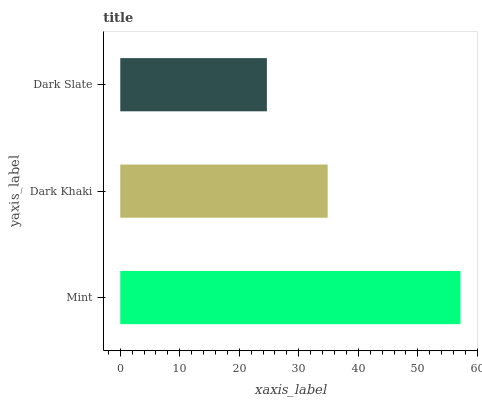Is Dark Slate the minimum?
Answer yes or no. Yes. Is Mint the maximum?
Answer yes or no. Yes. Is Dark Khaki the minimum?
Answer yes or no. No. Is Dark Khaki the maximum?
Answer yes or no. No. Is Mint greater than Dark Khaki?
Answer yes or no. Yes. Is Dark Khaki less than Mint?
Answer yes or no. Yes. Is Dark Khaki greater than Mint?
Answer yes or no. No. Is Mint less than Dark Khaki?
Answer yes or no. No. Is Dark Khaki the high median?
Answer yes or no. Yes. Is Dark Khaki the low median?
Answer yes or no. Yes. Is Dark Slate the high median?
Answer yes or no. No. Is Dark Slate the low median?
Answer yes or no. No. 